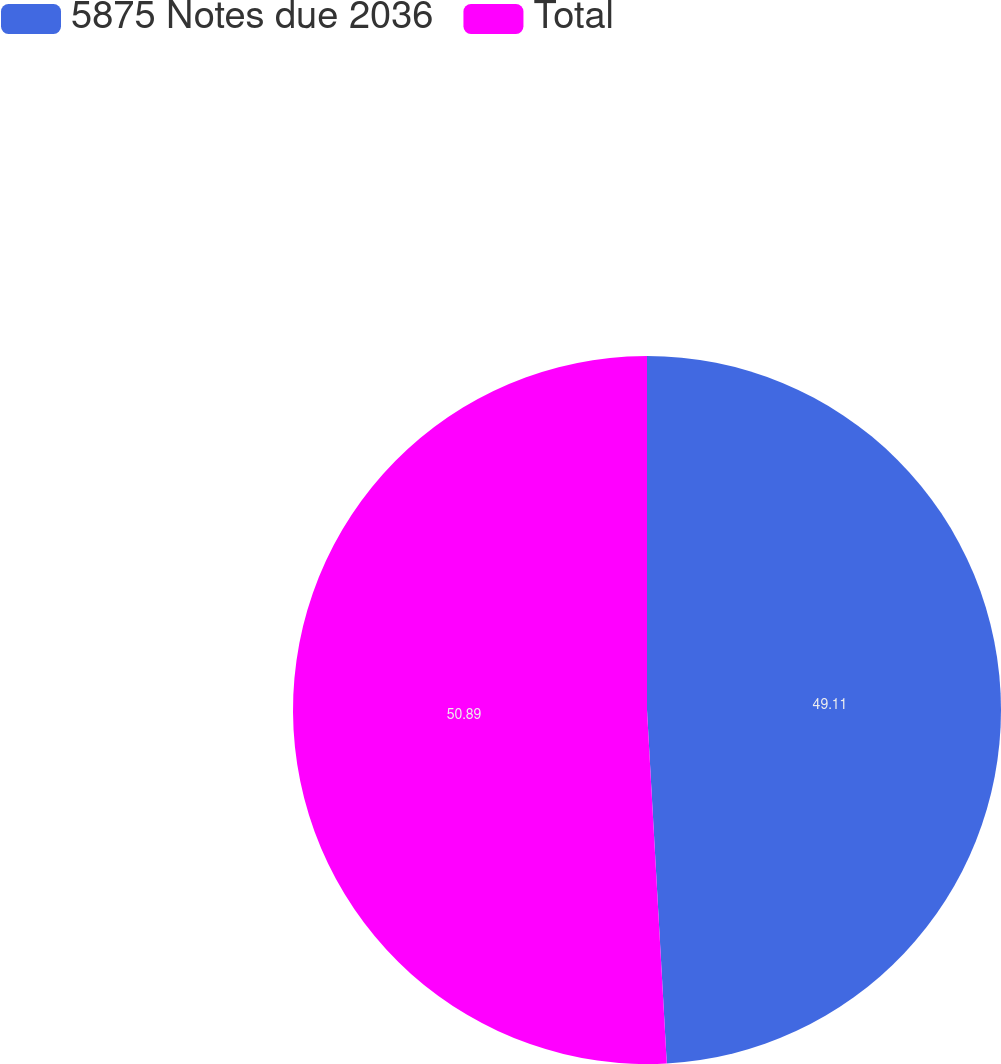<chart> <loc_0><loc_0><loc_500><loc_500><pie_chart><fcel>5875 Notes due 2036<fcel>Total<nl><fcel>49.11%<fcel>50.89%<nl></chart> 